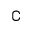<formula> <loc_0><loc_0><loc_500><loc_500>\complement</formula> 